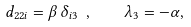Convert formula to latex. <formula><loc_0><loc_0><loc_500><loc_500>d _ { 2 2 i } = \beta \, \delta _ { i 3 } \ , \quad \lambda _ { 3 } = - \alpha ,</formula> 